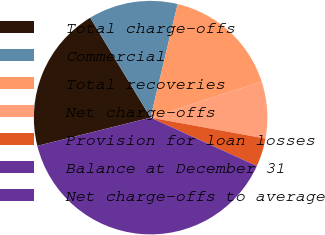Convert chart. <chart><loc_0><loc_0><loc_500><loc_500><pie_chart><fcel>Total charge-offs<fcel>Commercial<fcel>Total recoveries<fcel>Net charge-offs<fcel>Provision for loan losses<fcel>Balance at December 31<fcel>Net charge-offs to average<nl><fcel>20.23%<fcel>12.37%<fcel>16.3%<fcel>7.86%<fcel>3.93%<fcel>39.31%<fcel>0.0%<nl></chart> 